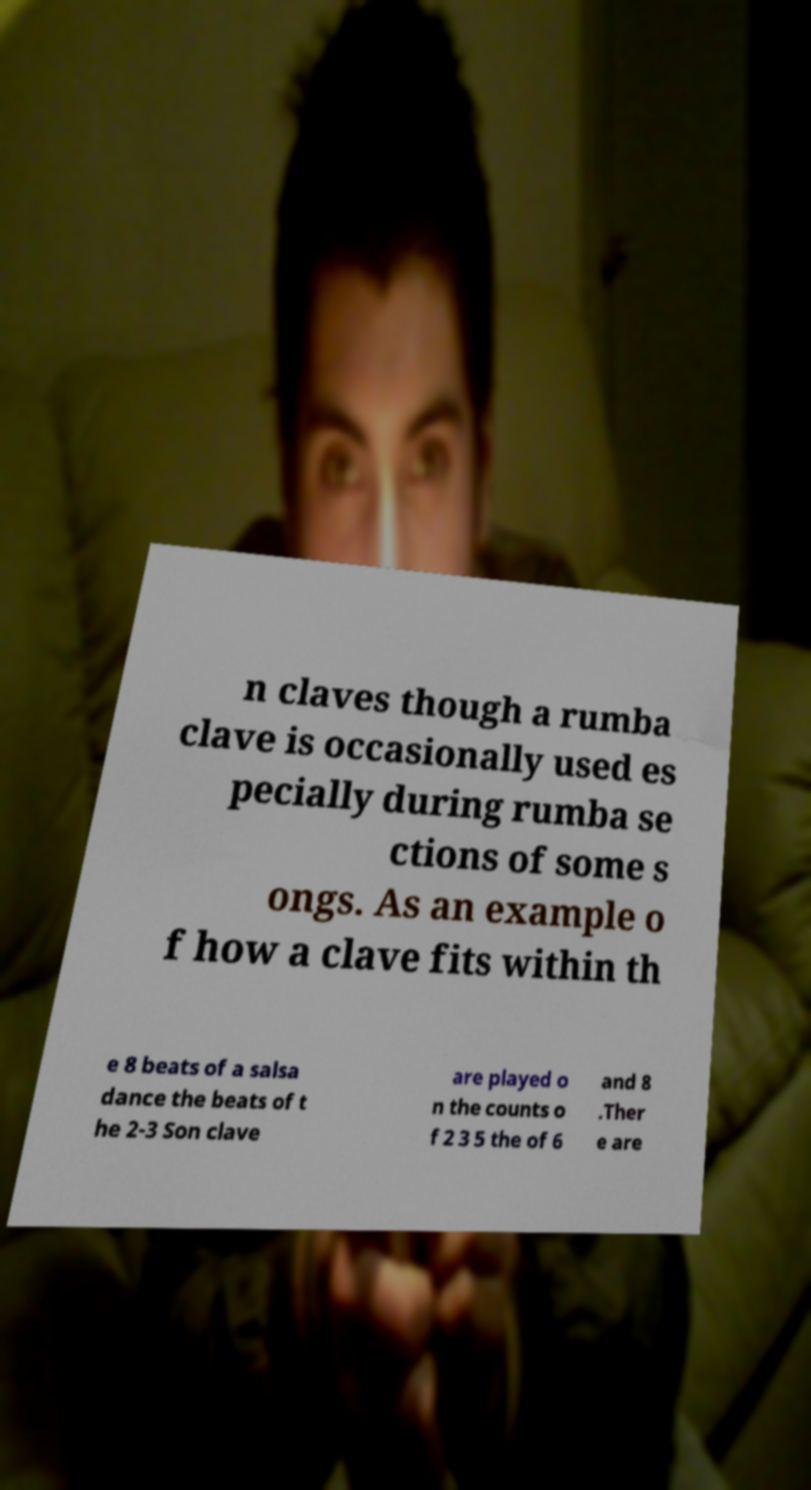I need the written content from this picture converted into text. Can you do that? n claves though a rumba clave is occasionally used es pecially during rumba se ctions of some s ongs. As an example o f how a clave fits within th e 8 beats of a salsa dance the beats of t he 2-3 Son clave are played o n the counts o f 2 3 5 the of 6 and 8 .Ther e are 